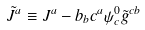Convert formula to latex. <formula><loc_0><loc_0><loc_500><loc_500>\tilde { J } ^ { a } \equiv J ^ { a } - b _ { b } c ^ { a } \psi ^ { 0 } _ { c } \tilde { g } ^ { c b }</formula> 